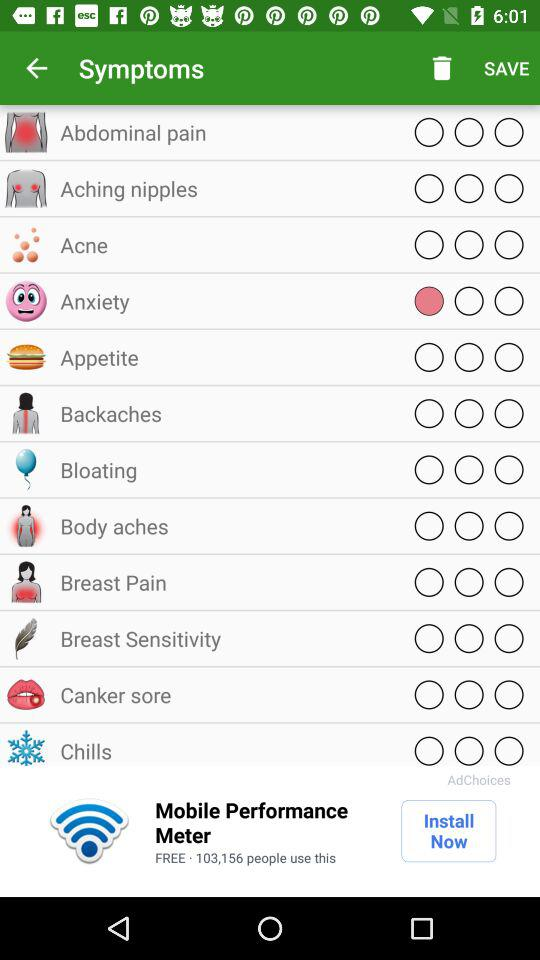What is the selected symptoms?
When the provided information is insufficient, respond with <no answer>. <no answer> 